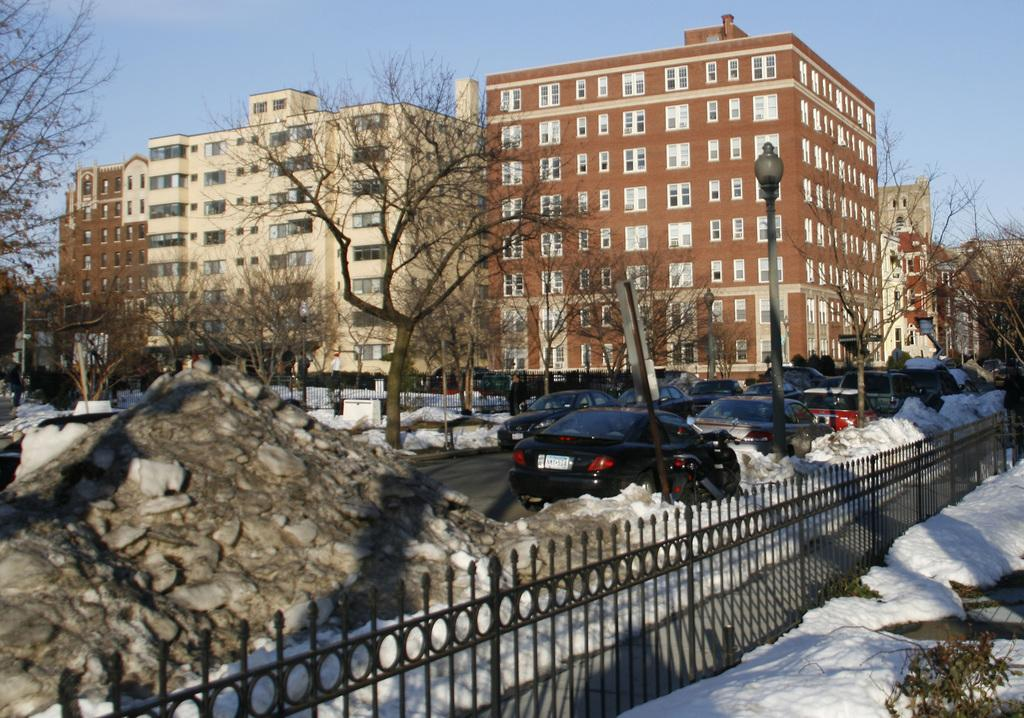What can be seen in the image that moves or transports people or goods? There are vehicles in the image. What type of weather condition is depicted in the image? There is snow visible in the image. What are the light sources in the image? There are lights on poles in the image. What type of natural elements are present in the image? There are trees in the image. What type of man-made structures can be seen in the background of the image? There are buildings in the background of the image. What is visible in the sky in the image? The sky is visible in the background of the image. How many spiders are crawling on the wall in the image? There are no spiders or walls present in the image. What type of conversation is taking place between the vehicles in the image? There is no conversation taking place between the vehicles in the image, as vehicles do not engage in conversation. 